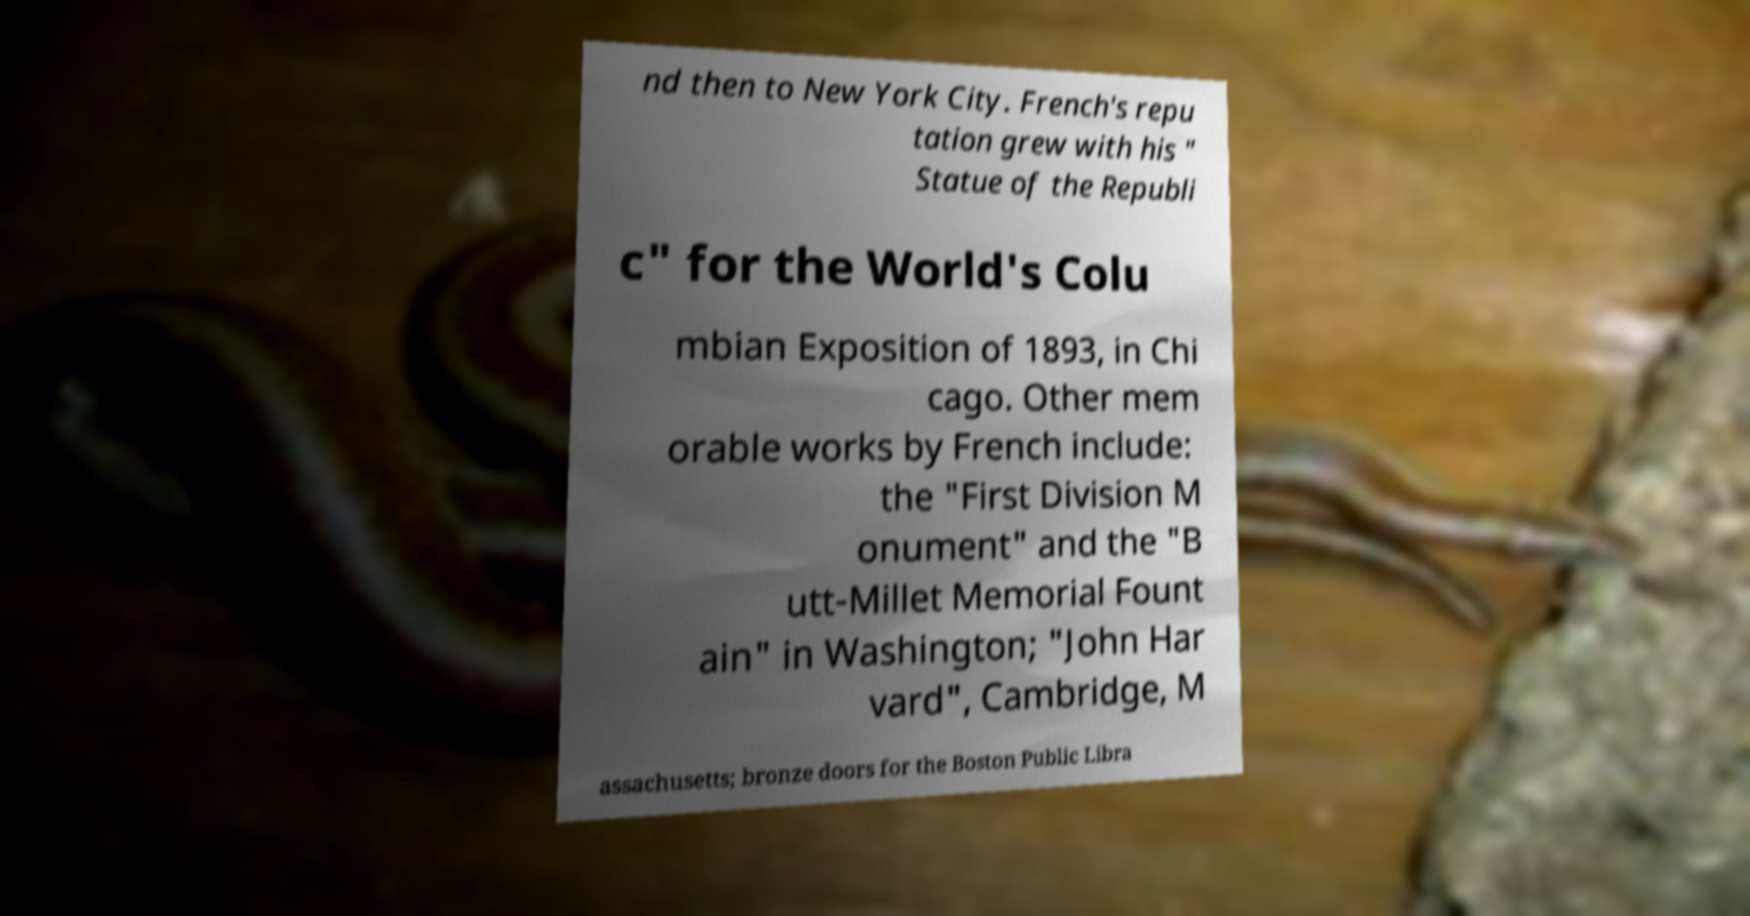Please identify and transcribe the text found in this image. nd then to New York City. French's repu tation grew with his " Statue of the Republi c" for the World's Colu mbian Exposition of 1893, in Chi cago. Other mem orable works by French include: the "First Division M onument" and the "B utt-Millet Memorial Fount ain" in Washington; "John Har vard", Cambridge, M assachusetts; bronze doors for the Boston Public Libra 